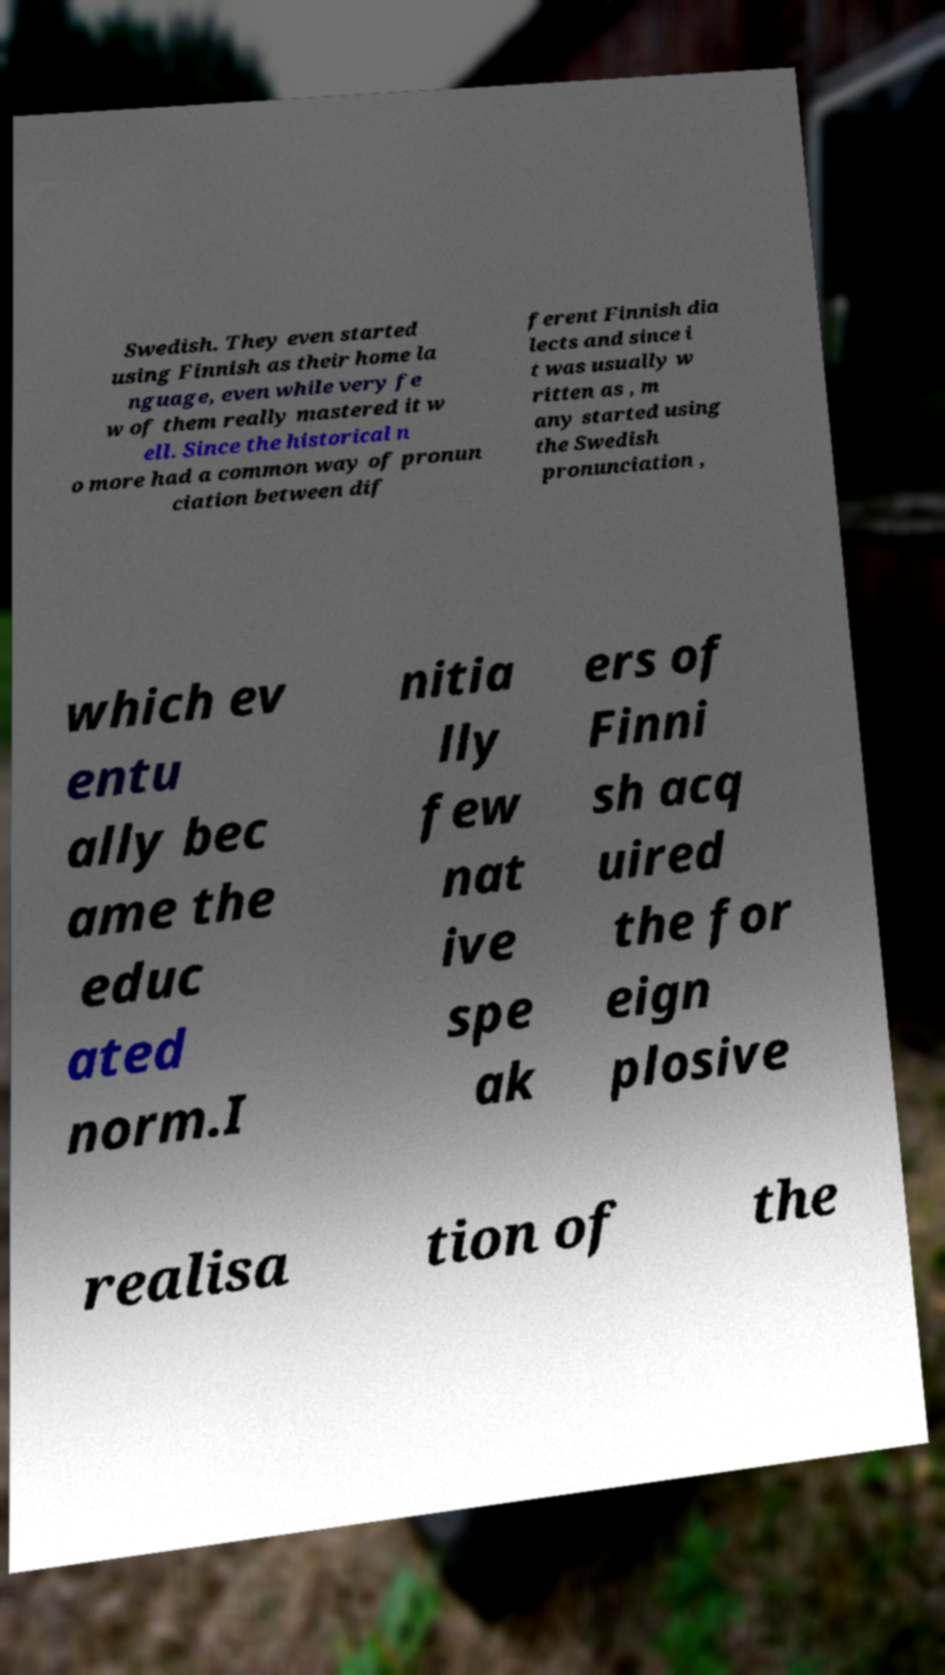For documentation purposes, I need the text within this image transcribed. Could you provide that? Swedish. They even started using Finnish as their home la nguage, even while very fe w of them really mastered it w ell. Since the historical n o more had a common way of pronun ciation between dif ferent Finnish dia lects and since i t was usually w ritten as , m any started using the Swedish pronunciation , which ev entu ally bec ame the educ ated norm.I nitia lly few nat ive spe ak ers of Finni sh acq uired the for eign plosive realisa tion of the 